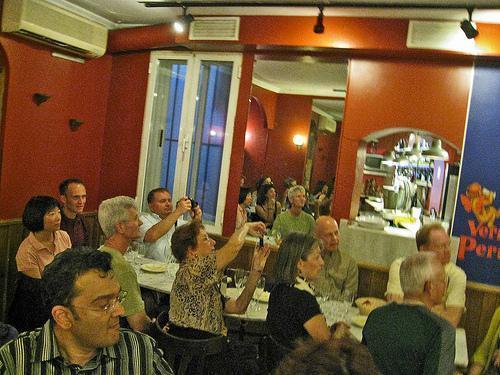How many people are holding up cameras?
Give a very brief answer. 2. How many women can be seen?
Give a very brief answer. 3. 